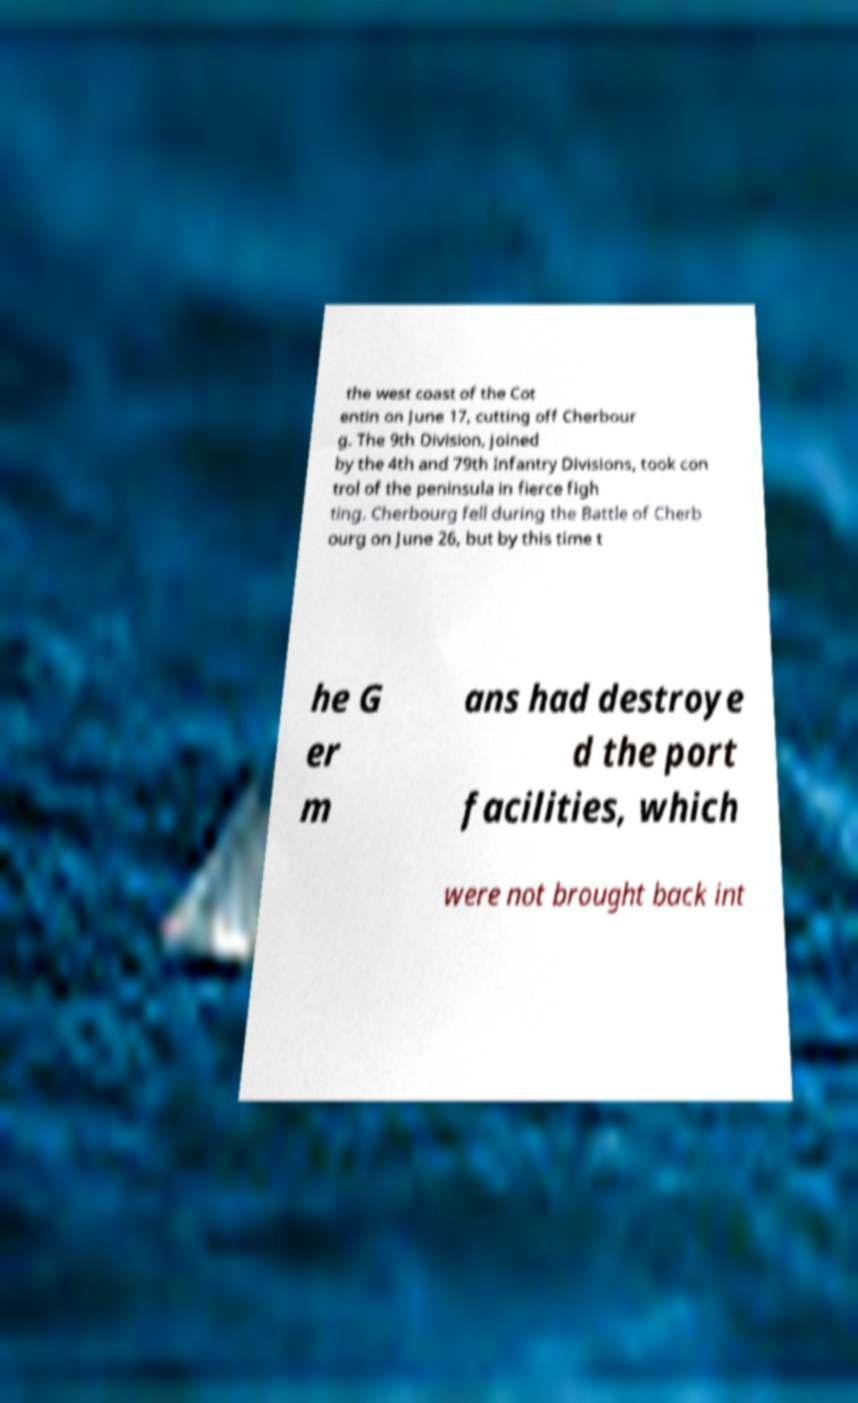Can you accurately transcribe the text from the provided image for me? the west coast of the Cot entin on June 17, cutting off Cherbour g. The 9th Division, joined by the 4th and 79th Infantry Divisions, took con trol of the peninsula in fierce figh ting. Cherbourg fell during the Battle of Cherb ourg on June 26, but by this time t he G er m ans had destroye d the port facilities, which were not brought back int 